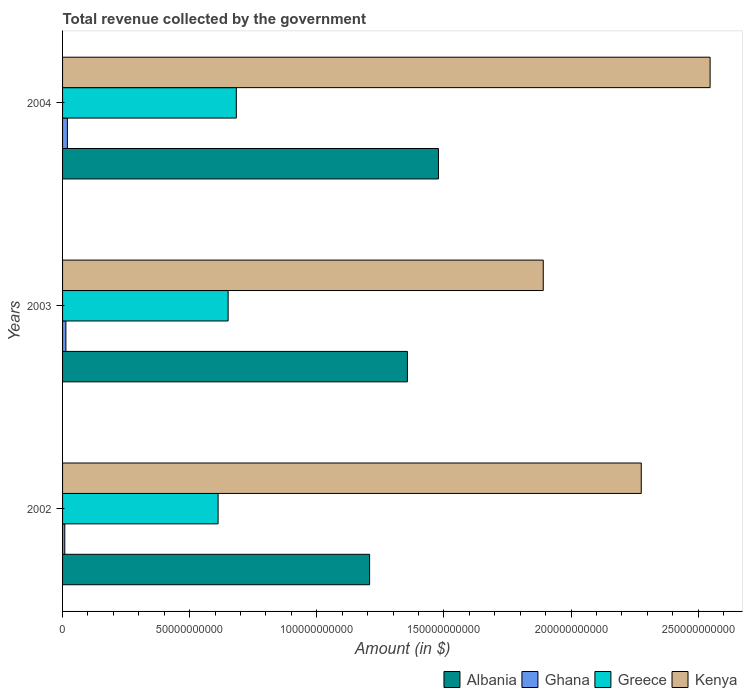Are the number of bars per tick equal to the number of legend labels?
Your response must be concise. Yes. Are the number of bars on each tick of the Y-axis equal?
Your answer should be compact. Yes. How many bars are there on the 3rd tick from the top?
Offer a terse response. 4. What is the total revenue collected by the government in Kenya in 2003?
Provide a short and direct response. 1.89e+11. Across all years, what is the maximum total revenue collected by the government in Greece?
Make the answer very short. 6.83e+1. Across all years, what is the minimum total revenue collected by the government in Kenya?
Your response must be concise. 1.89e+11. In which year was the total revenue collected by the government in Albania maximum?
Give a very brief answer. 2004. What is the total total revenue collected by the government in Albania in the graph?
Make the answer very short. 4.04e+11. What is the difference between the total revenue collected by the government in Kenya in 2002 and that in 2003?
Your answer should be compact. 3.86e+1. What is the difference between the total revenue collected by the government in Albania in 2004 and the total revenue collected by the government in Ghana in 2002?
Give a very brief answer. 1.47e+11. What is the average total revenue collected by the government in Greece per year?
Ensure brevity in your answer.  6.49e+1. In the year 2003, what is the difference between the total revenue collected by the government in Albania and total revenue collected by the government in Greece?
Offer a very short reply. 7.05e+1. In how many years, is the total revenue collected by the government in Ghana greater than 60000000000 $?
Provide a succinct answer. 0. What is the ratio of the total revenue collected by the government in Greece in 2003 to that in 2004?
Provide a succinct answer. 0.95. Is the difference between the total revenue collected by the government in Albania in 2002 and 2003 greater than the difference between the total revenue collected by the government in Greece in 2002 and 2003?
Your answer should be very brief. No. What is the difference between the highest and the second highest total revenue collected by the government in Kenya?
Give a very brief answer. 2.71e+1. What is the difference between the highest and the lowest total revenue collected by the government in Kenya?
Ensure brevity in your answer.  6.56e+1. In how many years, is the total revenue collected by the government in Greece greater than the average total revenue collected by the government in Greece taken over all years?
Make the answer very short. 2. Is it the case that in every year, the sum of the total revenue collected by the government in Greece and total revenue collected by the government in Albania is greater than the sum of total revenue collected by the government in Ghana and total revenue collected by the government in Kenya?
Provide a short and direct response. Yes. What does the 1st bar from the top in 2004 represents?
Your answer should be very brief. Kenya. What does the 4th bar from the bottom in 2002 represents?
Offer a terse response. Kenya. Are the values on the major ticks of X-axis written in scientific E-notation?
Your response must be concise. No. Does the graph contain any zero values?
Offer a very short reply. No. Does the graph contain grids?
Your answer should be very brief. No. How many legend labels are there?
Your answer should be compact. 4. What is the title of the graph?
Your answer should be compact. Total revenue collected by the government. Does "United Kingdom" appear as one of the legend labels in the graph?
Offer a terse response. No. What is the label or title of the X-axis?
Provide a succinct answer. Amount (in $). What is the Amount (in $) in Albania in 2002?
Offer a terse response. 1.21e+11. What is the Amount (in $) of Ghana in 2002?
Your response must be concise. 8.80e+08. What is the Amount (in $) in Greece in 2002?
Provide a short and direct response. 6.12e+1. What is the Amount (in $) of Kenya in 2002?
Make the answer very short. 2.28e+11. What is the Amount (in $) in Albania in 2003?
Your answer should be very brief. 1.36e+11. What is the Amount (in $) of Ghana in 2003?
Keep it short and to the point. 1.31e+09. What is the Amount (in $) of Greece in 2003?
Make the answer very short. 6.51e+1. What is the Amount (in $) of Kenya in 2003?
Offer a terse response. 1.89e+11. What is the Amount (in $) of Albania in 2004?
Offer a very short reply. 1.48e+11. What is the Amount (in $) of Ghana in 2004?
Offer a very short reply. 1.89e+09. What is the Amount (in $) in Greece in 2004?
Keep it short and to the point. 6.83e+1. What is the Amount (in $) in Kenya in 2004?
Provide a succinct answer. 2.55e+11. Across all years, what is the maximum Amount (in $) of Albania?
Give a very brief answer. 1.48e+11. Across all years, what is the maximum Amount (in $) of Ghana?
Your answer should be compact. 1.89e+09. Across all years, what is the maximum Amount (in $) of Greece?
Make the answer very short. 6.83e+1. Across all years, what is the maximum Amount (in $) of Kenya?
Your answer should be very brief. 2.55e+11. Across all years, what is the minimum Amount (in $) of Albania?
Your answer should be compact. 1.21e+11. Across all years, what is the minimum Amount (in $) of Ghana?
Your answer should be compact. 8.80e+08. Across all years, what is the minimum Amount (in $) in Greece?
Keep it short and to the point. 6.12e+1. Across all years, what is the minimum Amount (in $) of Kenya?
Give a very brief answer. 1.89e+11. What is the total Amount (in $) in Albania in the graph?
Offer a very short reply. 4.04e+11. What is the total Amount (in $) of Ghana in the graph?
Provide a succinct answer. 4.08e+09. What is the total Amount (in $) of Greece in the graph?
Your answer should be compact. 1.95e+11. What is the total Amount (in $) of Kenya in the graph?
Offer a very short reply. 6.71e+11. What is the difference between the Amount (in $) in Albania in 2002 and that in 2003?
Keep it short and to the point. -1.49e+1. What is the difference between the Amount (in $) of Ghana in 2002 and that in 2003?
Your answer should be compact. -4.28e+08. What is the difference between the Amount (in $) in Greece in 2002 and that in 2003?
Offer a very short reply. -3.95e+09. What is the difference between the Amount (in $) of Kenya in 2002 and that in 2003?
Provide a succinct answer. 3.86e+1. What is the difference between the Amount (in $) of Albania in 2002 and that in 2004?
Make the answer very short. -2.71e+1. What is the difference between the Amount (in $) in Ghana in 2002 and that in 2004?
Ensure brevity in your answer.  -1.01e+09. What is the difference between the Amount (in $) of Greece in 2002 and that in 2004?
Keep it short and to the point. -7.17e+09. What is the difference between the Amount (in $) in Kenya in 2002 and that in 2004?
Your answer should be compact. -2.71e+1. What is the difference between the Amount (in $) in Albania in 2003 and that in 2004?
Offer a terse response. -1.22e+1. What is the difference between the Amount (in $) of Ghana in 2003 and that in 2004?
Give a very brief answer. -5.87e+08. What is the difference between the Amount (in $) of Greece in 2003 and that in 2004?
Your response must be concise. -3.22e+09. What is the difference between the Amount (in $) in Kenya in 2003 and that in 2004?
Provide a succinct answer. -6.56e+1. What is the difference between the Amount (in $) in Albania in 2002 and the Amount (in $) in Ghana in 2003?
Ensure brevity in your answer.  1.19e+11. What is the difference between the Amount (in $) of Albania in 2002 and the Amount (in $) of Greece in 2003?
Give a very brief answer. 5.56e+1. What is the difference between the Amount (in $) in Albania in 2002 and the Amount (in $) in Kenya in 2003?
Give a very brief answer. -6.83e+1. What is the difference between the Amount (in $) in Ghana in 2002 and the Amount (in $) in Greece in 2003?
Offer a terse response. -6.42e+1. What is the difference between the Amount (in $) of Ghana in 2002 and the Amount (in $) of Kenya in 2003?
Provide a succinct answer. -1.88e+11. What is the difference between the Amount (in $) of Greece in 2002 and the Amount (in $) of Kenya in 2003?
Your response must be concise. -1.28e+11. What is the difference between the Amount (in $) in Albania in 2002 and the Amount (in $) in Ghana in 2004?
Your response must be concise. 1.19e+11. What is the difference between the Amount (in $) of Albania in 2002 and the Amount (in $) of Greece in 2004?
Offer a very short reply. 5.24e+1. What is the difference between the Amount (in $) in Albania in 2002 and the Amount (in $) in Kenya in 2004?
Offer a very short reply. -1.34e+11. What is the difference between the Amount (in $) in Ghana in 2002 and the Amount (in $) in Greece in 2004?
Make the answer very short. -6.75e+1. What is the difference between the Amount (in $) in Ghana in 2002 and the Amount (in $) in Kenya in 2004?
Your answer should be very brief. -2.54e+11. What is the difference between the Amount (in $) of Greece in 2002 and the Amount (in $) of Kenya in 2004?
Make the answer very short. -1.94e+11. What is the difference between the Amount (in $) of Albania in 2003 and the Amount (in $) of Ghana in 2004?
Offer a terse response. 1.34e+11. What is the difference between the Amount (in $) in Albania in 2003 and the Amount (in $) in Greece in 2004?
Your response must be concise. 6.73e+1. What is the difference between the Amount (in $) of Albania in 2003 and the Amount (in $) of Kenya in 2004?
Your answer should be very brief. -1.19e+11. What is the difference between the Amount (in $) in Ghana in 2003 and the Amount (in $) in Greece in 2004?
Ensure brevity in your answer.  -6.70e+1. What is the difference between the Amount (in $) in Ghana in 2003 and the Amount (in $) in Kenya in 2004?
Ensure brevity in your answer.  -2.53e+11. What is the difference between the Amount (in $) of Greece in 2003 and the Amount (in $) of Kenya in 2004?
Your response must be concise. -1.90e+11. What is the average Amount (in $) of Albania per year?
Provide a succinct answer. 1.35e+11. What is the average Amount (in $) in Ghana per year?
Provide a short and direct response. 1.36e+09. What is the average Amount (in $) of Greece per year?
Your answer should be compact. 6.49e+1. What is the average Amount (in $) of Kenya per year?
Your answer should be compact. 2.24e+11. In the year 2002, what is the difference between the Amount (in $) of Albania and Amount (in $) of Ghana?
Provide a short and direct response. 1.20e+11. In the year 2002, what is the difference between the Amount (in $) in Albania and Amount (in $) in Greece?
Provide a succinct answer. 5.96e+1. In the year 2002, what is the difference between the Amount (in $) in Albania and Amount (in $) in Kenya?
Keep it short and to the point. -1.07e+11. In the year 2002, what is the difference between the Amount (in $) in Ghana and Amount (in $) in Greece?
Offer a very short reply. -6.03e+1. In the year 2002, what is the difference between the Amount (in $) of Ghana and Amount (in $) of Kenya?
Give a very brief answer. -2.27e+11. In the year 2002, what is the difference between the Amount (in $) in Greece and Amount (in $) in Kenya?
Give a very brief answer. -1.66e+11. In the year 2003, what is the difference between the Amount (in $) in Albania and Amount (in $) in Ghana?
Ensure brevity in your answer.  1.34e+11. In the year 2003, what is the difference between the Amount (in $) of Albania and Amount (in $) of Greece?
Give a very brief answer. 7.05e+1. In the year 2003, what is the difference between the Amount (in $) in Albania and Amount (in $) in Kenya?
Your response must be concise. -5.34e+1. In the year 2003, what is the difference between the Amount (in $) in Ghana and Amount (in $) in Greece?
Ensure brevity in your answer.  -6.38e+1. In the year 2003, what is the difference between the Amount (in $) in Ghana and Amount (in $) in Kenya?
Give a very brief answer. -1.88e+11. In the year 2003, what is the difference between the Amount (in $) in Greece and Amount (in $) in Kenya?
Keep it short and to the point. -1.24e+11. In the year 2004, what is the difference between the Amount (in $) in Albania and Amount (in $) in Ghana?
Ensure brevity in your answer.  1.46e+11. In the year 2004, what is the difference between the Amount (in $) in Albania and Amount (in $) in Greece?
Your answer should be compact. 7.95e+1. In the year 2004, what is the difference between the Amount (in $) of Albania and Amount (in $) of Kenya?
Make the answer very short. -1.07e+11. In the year 2004, what is the difference between the Amount (in $) in Ghana and Amount (in $) in Greece?
Make the answer very short. -6.64e+1. In the year 2004, what is the difference between the Amount (in $) of Ghana and Amount (in $) of Kenya?
Your response must be concise. -2.53e+11. In the year 2004, what is the difference between the Amount (in $) of Greece and Amount (in $) of Kenya?
Make the answer very short. -1.86e+11. What is the ratio of the Amount (in $) in Albania in 2002 to that in 2003?
Your answer should be very brief. 0.89. What is the ratio of the Amount (in $) in Ghana in 2002 to that in 2003?
Your answer should be compact. 0.67. What is the ratio of the Amount (in $) in Greece in 2002 to that in 2003?
Your answer should be compact. 0.94. What is the ratio of the Amount (in $) in Kenya in 2002 to that in 2003?
Provide a short and direct response. 1.2. What is the ratio of the Amount (in $) in Albania in 2002 to that in 2004?
Your answer should be very brief. 0.82. What is the ratio of the Amount (in $) of Ghana in 2002 to that in 2004?
Ensure brevity in your answer.  0.46. What is the ratio of the Amount (in $) of Greece in 2002 to that in 2004?
Provide a succinct answer. 0.9. What is the ratio of the Amount (in $) of Kenya in 2002 to that in 2004?
Your answer should be very brief. 0.89. What is the ratio of the Amount (in $) in Albania in 2003 to that in 2004?
Your answer should be compact. 0.92. What is the ratio of the Amount (in $) in Ghana in 2003 to that in 2004?
Provide a succinct answer. 0.69. What is the ratio of the Amount (in $) of Greece in 2003 to that in 2004?
Provide a succinct answer. 0.95. What is the ratio of the Amount (in $) of Kenya in 2003 to that in 2004?
Make the answer very short. 0.74. What is the difference between the highest and the second highest Amount (in $) in Albania?
Your answer should be compact. 1.22e+1. What is the difference between the highest and the second highest Amount (in $) of Ghana?
Offer a terse response. 5.87e+08. What is the difference between the highest and the second highest Amount (in $) of Greece?
Provide a succinct answer. 3.22e+09. What is the difference between the highest and the second highest Amount (in $) in Kenya?
Ensure brevity in your answer.  2.71e+1. What is the difference between the highest and the lowest Amount (in $) of Albania?
Your answer should be very brief. 2.71e+1. What is the difference between the highest and the lowest Amount (in $) of Ghana?
Provide a succinct answer. 1.01e+09. What is the difference between the highest and the lowest Amount (in $) of Greece?
Provide a succinct answer. 7.17e+09. What is the difference between the highest and the lowest Amount (in $) in Kenya?
Keep it short and to the point. 6.56e+1. 